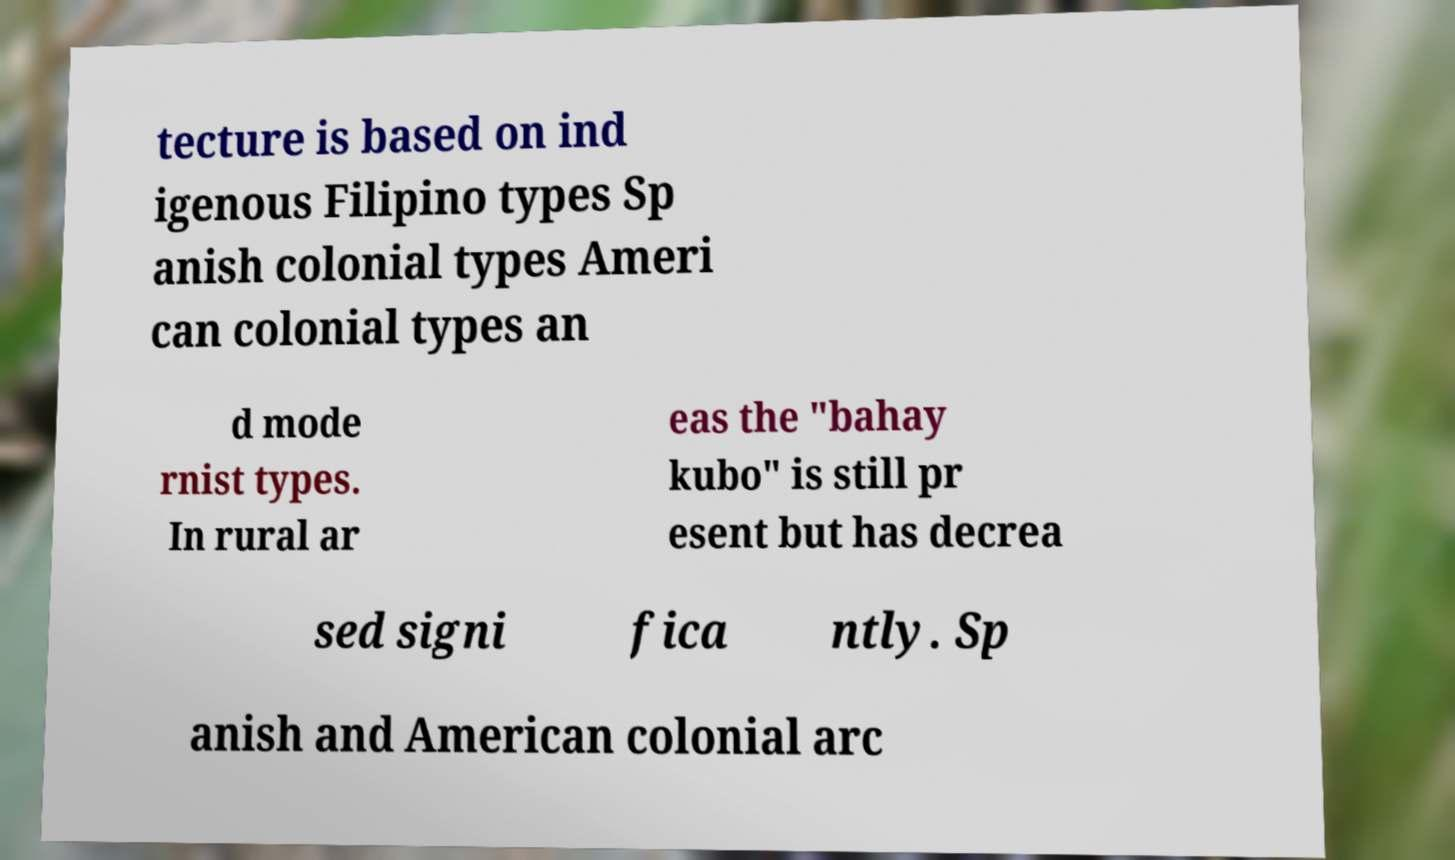For documentation purposes, I need the text within this image transcribed. Could you provide that? tecture is based on ind igenous Filipino types Sp anish colonial types Ameri can colonial types an d mode rnist types. In rural ar eas the "bahay kubo" is still pr esent but has decrea sed signi fica ntly. Sp anish and American colonial arc 